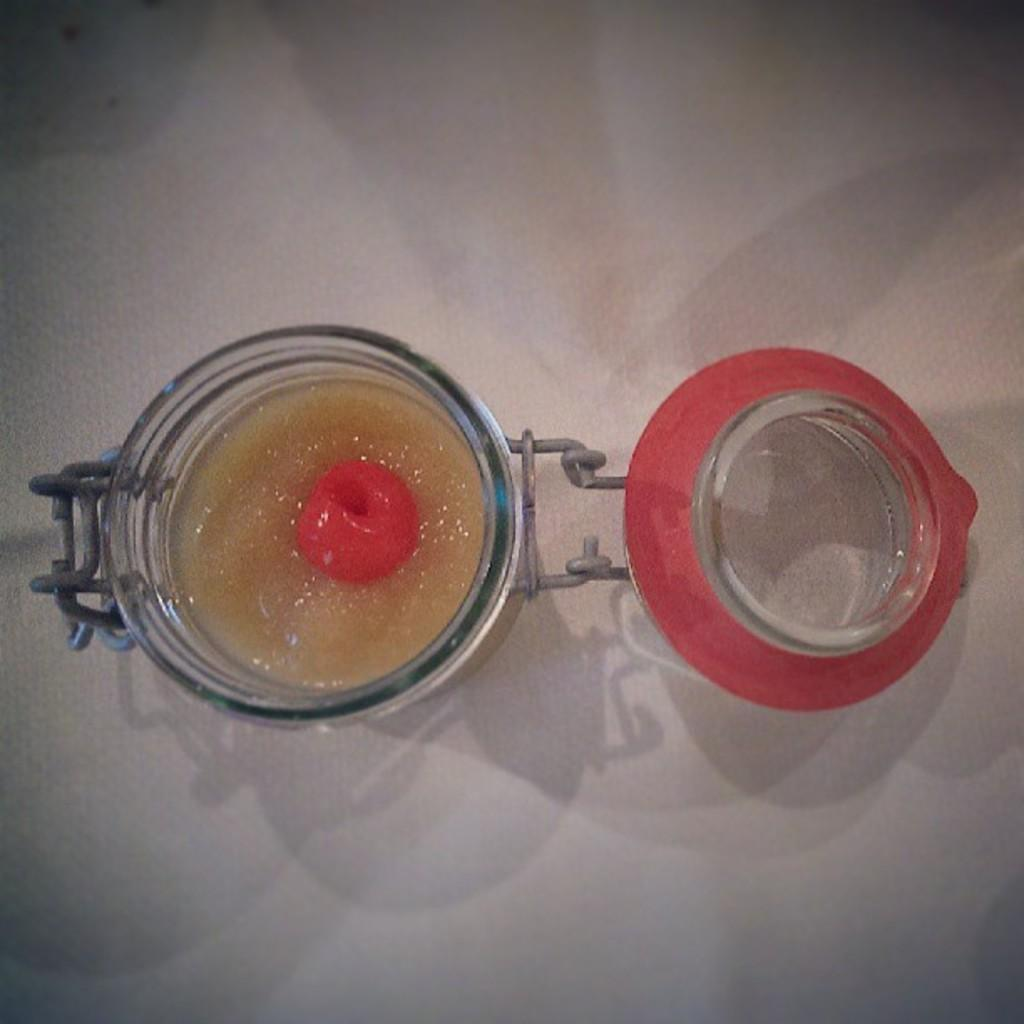What is located on the table in the image? There is a picture on the table in the image. What can be seen in the picture? The picture contains food items. What type of test can be seen being administered in the image? There is no test present in the image; it contains a picture with food items. Can you hear the voice of the person in the image? There is no person present in the image, so it is not possible to hear their voice. 